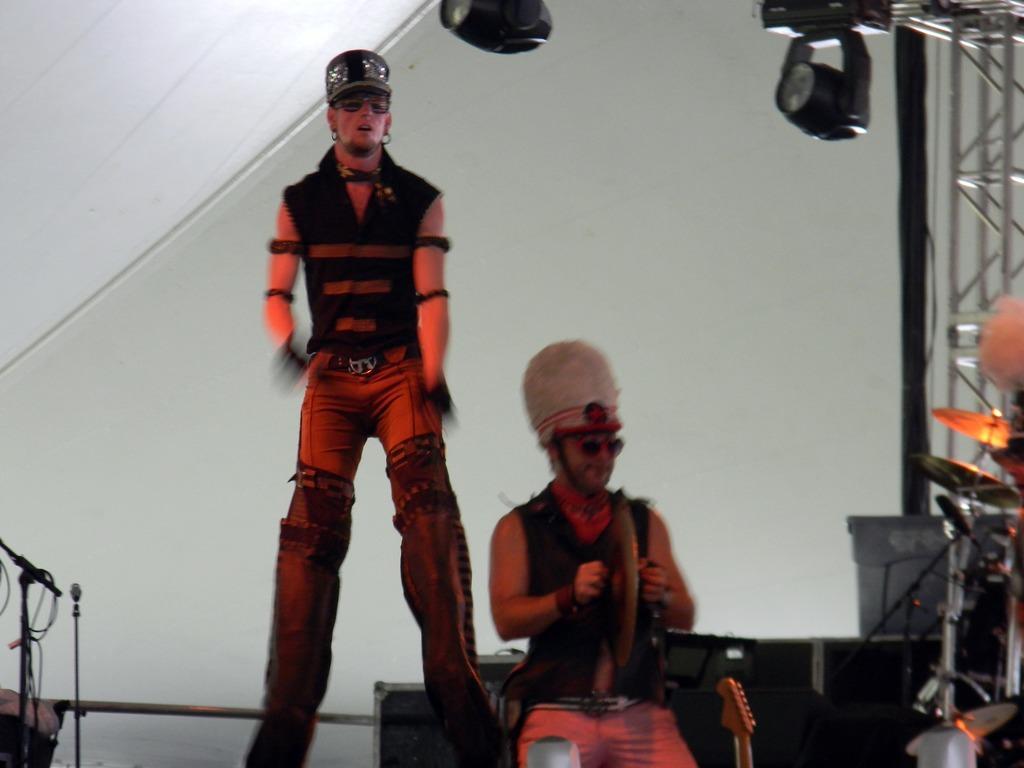Please provide a concise description of this image. In this picture there are two men. In the bottom left side of the image we can see stands and cable. On the right side of the image we can see musical instruments. In the background of the image we can see rods, lights, wall and few objects. 